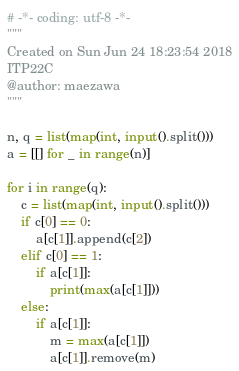<code> <loc_0><loc_0><loc_500><loc_500><_Python_># -*- coding: utf-8 -*-
"""
Created on Sun Jun 24 18:23:54 2018
ITP22C
@author: maezawa
"""

n, q = list(map(int, input().split()))
a = [[] for _ in range(n)]

for i in range(q):
    c = list(map(int, input().split()))
    if c[0] == 0:
        a[c[1]].append(c[2])
    elif c[0] == 1:
        if a[c[1]]:
            print(max(a[c[1]]))
    else:
        if a[c[1]]:
            m = max(a[c[1]])
            a[c[1]].remove(m)


</code> 